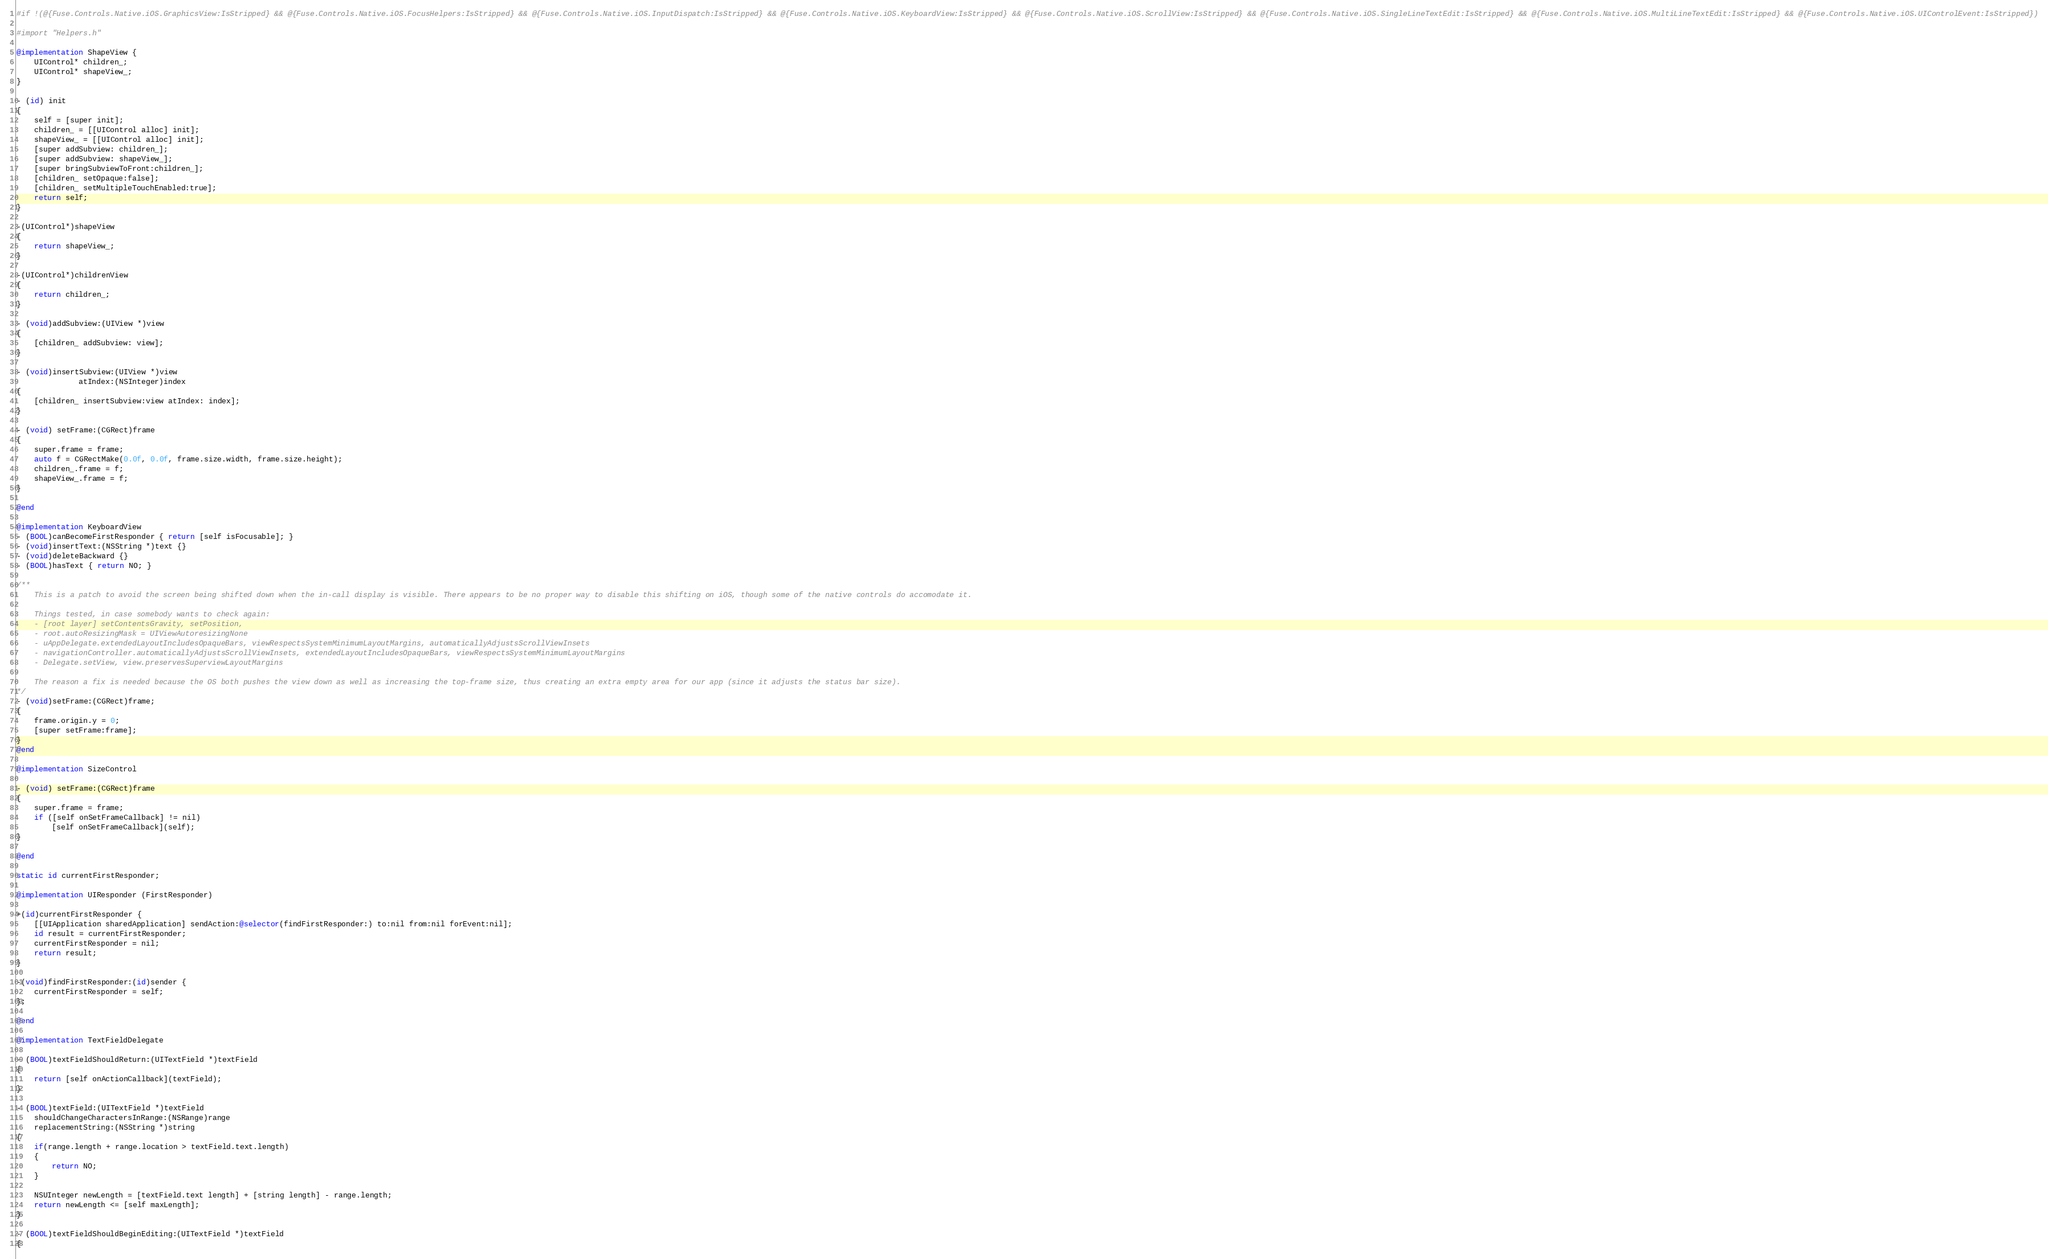Convert code to text. <code><loc_0><loc_0><loc_500><loc_500><_ObjectiveC_>#if !(@{Fuse.Controls.Native.iOS.GraphicsView:IsStripped} && @{Fuse.Controls.Native.iOS.FocusHelpers:IsStripped} && @{Fuse.Controls.Native.iOS.InputDispatch:IsStripped} && @{Fuse.Controls.Native.iOS.KeyboardView:IsStripped} && @{Fuse.Controls.Native.iOS.ScrollView:IsStripped} && @{Fuse.Controls.Native.iOS.SingleLineTextEdit:IsStripped} && @{Fuse.Controls.Native.iOS.MultiLineTextEdit:IsStripped} && @{Fuse.Controls.Native.iOS.UIControlEvent:IsStripped})

#import "Helpers.h"

@implementation ShapeView {
	UIControl* children_;
	UIControl* shapeView_;
}

- (id) init
{
	self = [super init];
	children_ = [[UIControl alloc] init];
	shapeView_ = [[UIControl alloc] init];
	[super addSubview: children_];
	[super addSubview: shapeView_];
	[super bringSubviewToFront:children_];
	[children_ setOpaque:false];
	[children_ setMultipleTouchEnabled:true];
	return self;
}

-(UIControl*)shapeView
{
	return shapeView_;
}

-(UIControl*)childrenView
{
	return children_;
}

- (void)addSubview:(UIView *)view
{
	[children_ addSubview: view];
}

- (void)insertSubview:(UIView *)view
			  atIndex:(NSInteger)index
{
	[children_ insertSubview:view atIndex: index];
}

- (void) setFrame:(CGRect)frame
{
	super.frame = frame;
	auto f = CGRectMake(0.0f, 0.0f, frame.size.width, frame.size.height);
	children_.frame = f;
	shapeView_.frame = f;
}

@end

@implementation KeyboardView
- (BOOL)canBecomeFirstResponder { return [self isFocusable]; }
- (void)insertText:(NSString *)text {}
- (void)deleteBackward {}
- (BOOL)hasText { return NO; }

/**
	This is a patch to avoid the screen being shifted down when the in-call display is visible. There appears to be no proper way to disable this shifting on iOS, though some of the native controls do accomodate it.

	Things tested, in case somebody wants to check again:
	- [root layer] setContentsGravity, setPosition,
	- root.autoResizingMask = UIViewAutoresizingNone
	- uAppDelegate.extendedLayoutIncludesOpaqueBars, viewRespectsSystemMinimumLayoutMargins, automaticallyAdjustsScrollViewInsets
	- navigationController.automaticallyAdjustsScrollViewInsets, extendedLayoutIncludesOpaqueBars, viewRespectsSystemMinimumLayoutMargins
	- Delegate.setView, view.preservesSuperviewLayoutMargins

	The reason a fix is needed because the OS both pushes the view down as well as increasing the top-frame size, thus creating an extra empty area for our app (since it adjusts the status bar size).
*/
- (void)setFrame:(CGRect)frame;
{
	frame.origin.y = 0;
	[super setFrame:frame];
}
@end

@implementation SizeControl

- (void) setFrame:(CGRect)frame
{
	super.frame = frame;
	if ([self onSetFrameCallback] != nil)
		[self onSetFrameCallback](self);
}

@end

static id currentFirstResponder;

@implementation UIResponder (FirstResponder)

+(id)currentFirstResponder {
	[[UIApplication sharedApplication] sendAction:@selector(findFirstResponder:) to:nil from:nil forEvent:nil];
	id result = currentFirstResponder;
	currentFirstResponder = nil;
	return result;
}

-(void)findFirstResponder:(id)sender {
	currentFirstResponder = self;
};

@end

@implementation TextFieldDelegate

- (BOOL)textFieldShouldReturn:(UITextField *)textField
{
	return [self onActionCallback](textField);
}

- (BOOL)textField:(UITextField *)textField
	shouldChangeCharactersInRange:(NSRange)range
	replacementString:(NSString *)string
{
	if(range.length + range.location > textField.text.length)
	{
		return NO;
	}

	NSUInteger newLength = [textField.text length] + [string length] - range.length;
	return newLength <= [self maxLength];
}

- (BOOL)textFieldShouldBeginEditing:(UITextField *)textField
{</code> 